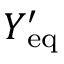<formula> <loc_0><loc_0><loc_500><loc_500>Y _ { e q } ^ { \prime }</formula> 